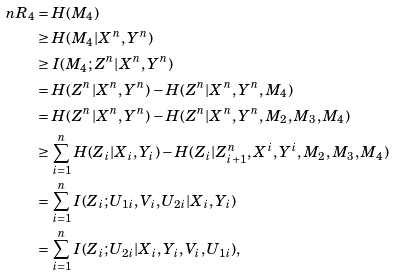<formula> <loc_0><loc_0><loc_500><loc_500>n R _ { 4 } & = H ( M _ { 4 } ) \\ & \geq H ( M _ { 4 } | X ^ { n } , Y ^ { n } ) \\ & \geq I ( M _ { 4 } ; Z ^ { n } | X ^ { n } , Y ^ { n } ) \\ & = H ( Z ^ { n } | X ^ { n } , Y ^ { n } ) - H ( Z ^ { n } | X ^ { n } , Y ^ { n } , M _ { 4 } ) \\ & = H ( Z ^ { n } | X ^ { n } , Y ^ { n } ) - H ( Z ^ { n } | X ^ { n } , Y ^ { n } , M _ { 2 } , M _ { 3 } , M _ { 4 } ) \\ & \geq \sum _ { i = 1 } ^ { n } H ( Z _ { i } | X _ { i } , Y _ { i } ) - H ( Z _ { i } | Z _ { i + 1 } ^ { n } , X ^ { i } , Y ^ { i } , M _ { 2 } , M _ { 3 } , M _ { 4 } ) \\ & = \sum _ { i = 1 } ^ { n } I ( Z _ { i } ; U _ { 1 i } , V _ { i } , U _ { 2 i } | X _ { i } , Y _ { i } ) \\ & = \sum _ { i = 1 } ^ { n } I ( Z _ { i } ; U _ { 2 i } | X _ { i } , Y _ { i } , V _ { i } , U _ { 1 i } ) ,</formula> 